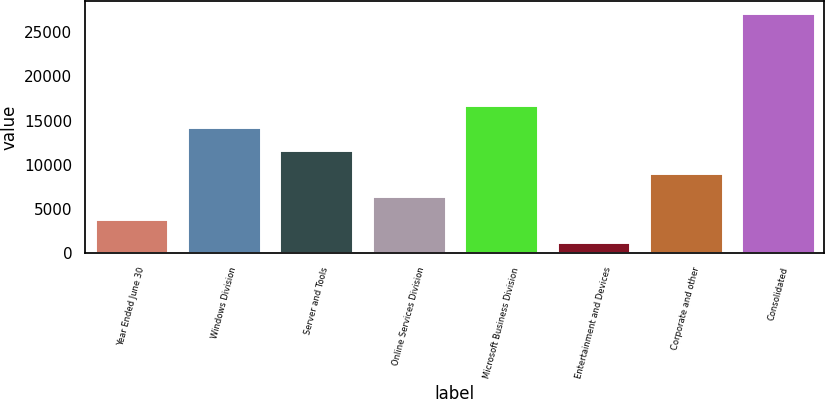Convert chart. <chart><loc_0><loc_0><loc_500><loc_500><bar_chart><fcel>Year Ended June 30<fcel>Windows Division<fcel>Server and Tools<fcel>Online Services Division<fcel>Microsoft Business Division<fcel>Entertainment and Devices<fcel>Corporate and other<fcel>Consolidated<nl><fcel>3885.2<fcel>14230<fcel>11643.8<fcel>6471.4<fcel>16816.2<fcel>1299<fcel>9057.6<fcel>27161<nl></chart> 